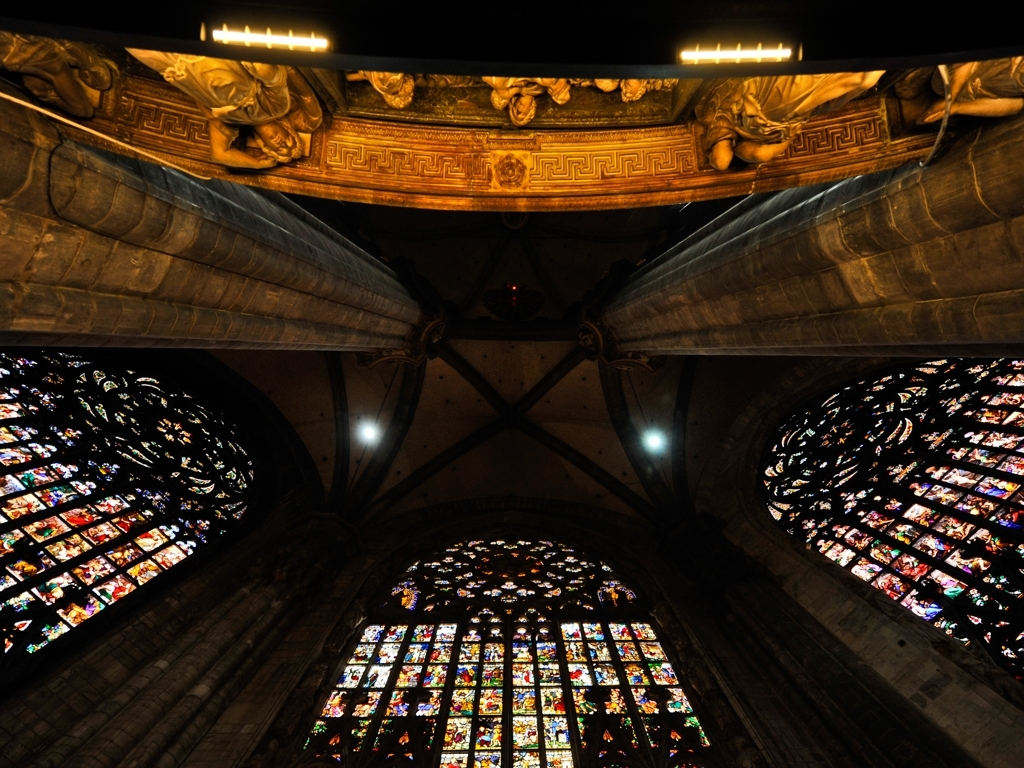Are there any distortions in the image?
A. Yes
B. No
Answer with the option's letter from the given choices directly. Upon examination, it appears there are no noticeable distortions in the image. The architectural elements, such as the rose windows and stone sculptures, all display clear and consistent geometry, which is characteristic of structural integrity and proper photographic capture with no warping effects. 